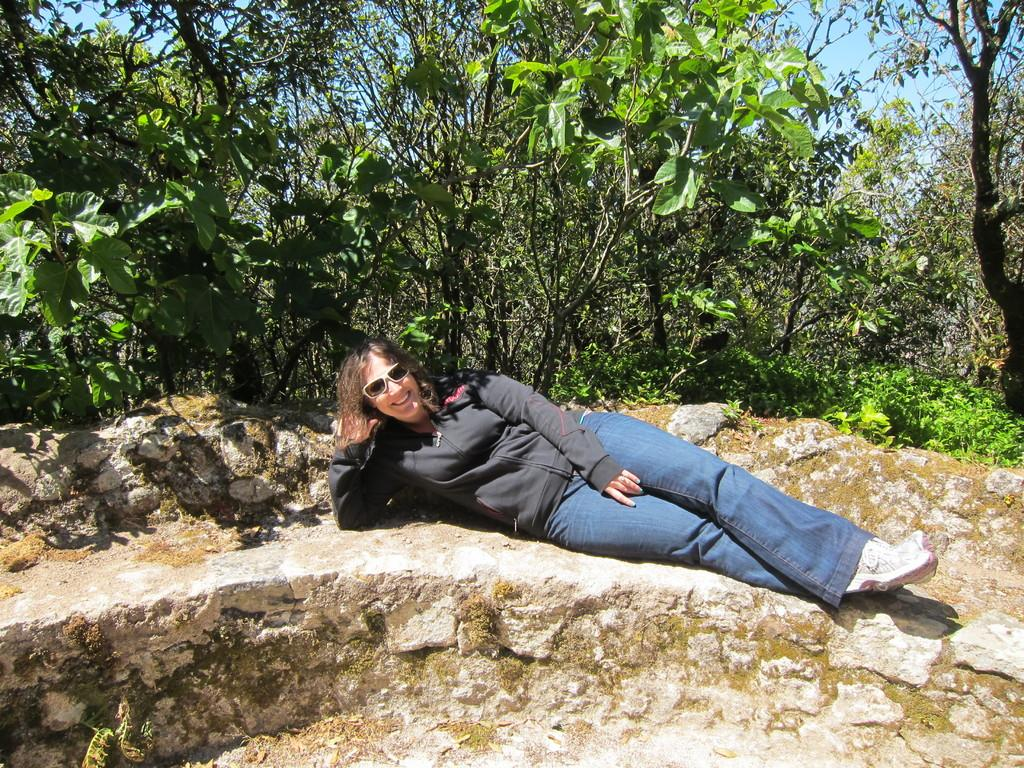Who is the main subject in the foreground of the image? There is a woman in the foreground of the image. What is the woman doing in the image? The woman is lying on a stone seat. What can be seen in the background of the image? There are trees and the sky visible in the background of the image. What type of bird is sitting in the woman's pocket in the image? There is no bird present in the image, and the woman does not have a pocket in the image. 